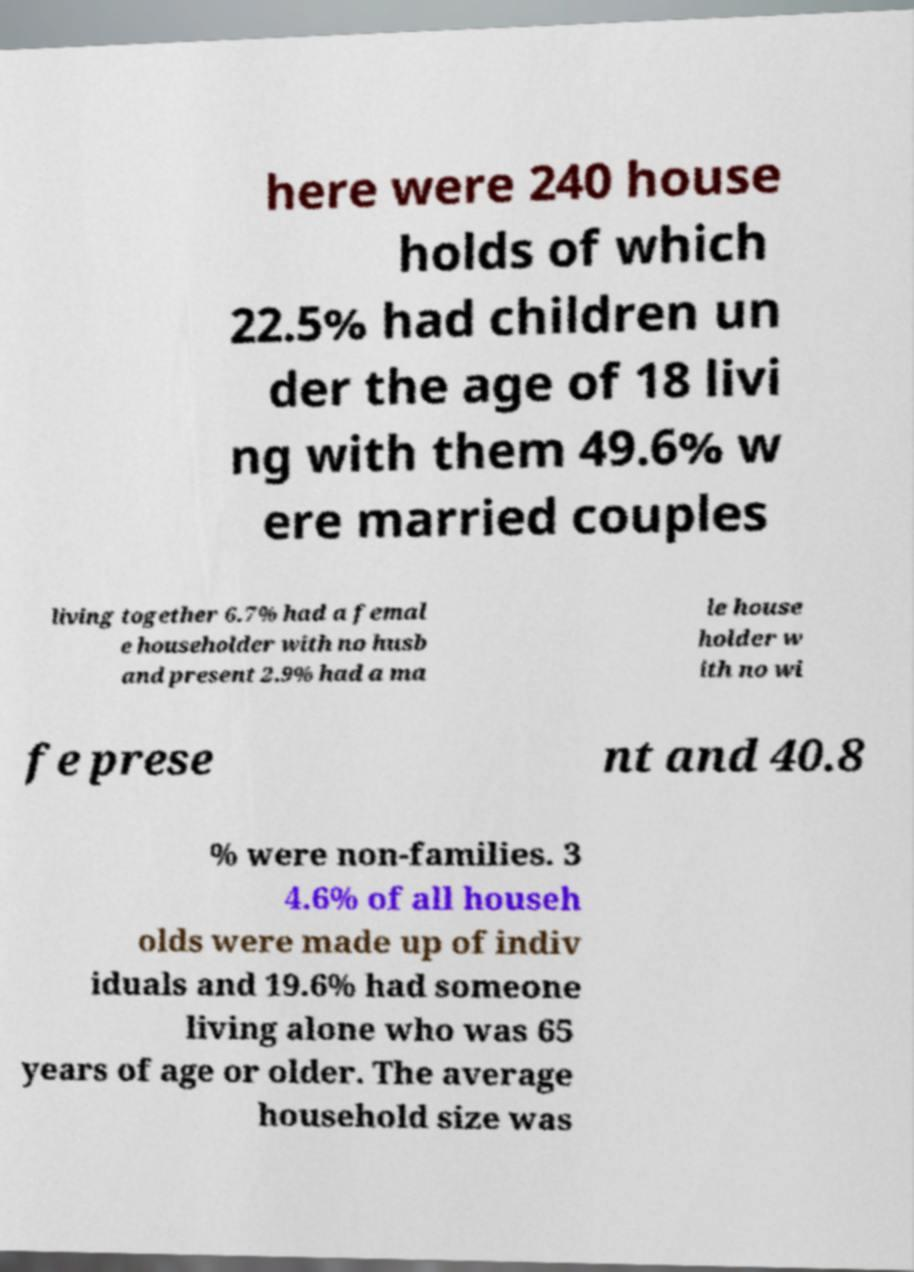I need the written content from this picture converted into text. Can you do that? here were 240 house holds of which 22.5% had children un der the age of 18 livi ng with them 49.6% w ere married couples living together 6.7% had a femal e householder with no husb and present 2.9% had a ma le house holder w ith no wi fe prese nt and 40.8 % were non-families. 3 4.6% of all househ olds were made up of indiv iduals and 19.6% had someone living alone who was 65 years of age or older. The average household size was 